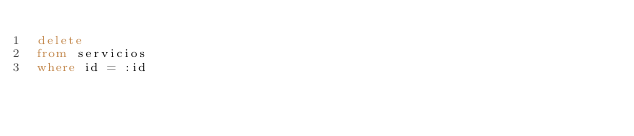<code> <loc_0><loc_0><loc_500><loc_500><_SQL_>delete 
from servicios
where id = :id</code> 